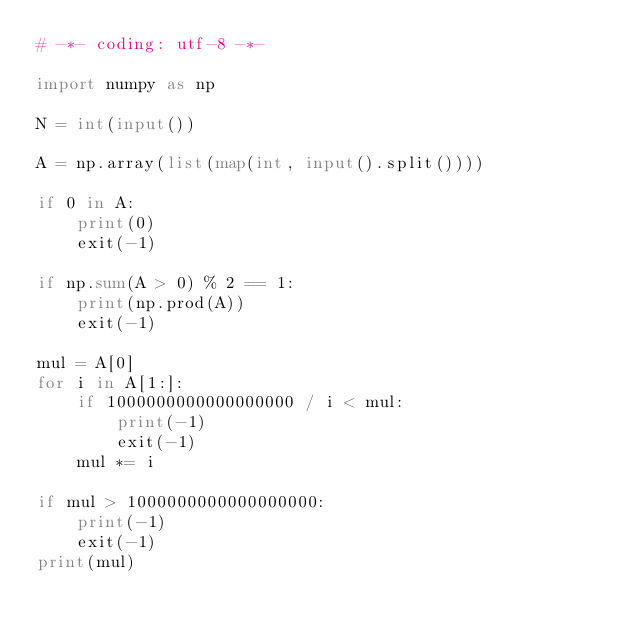Convert code to text. <code><loc_0><loc_0><loc_500><loc_500><_Python_># -*- coding: utf-8 -*-

import numpy as np

N = int(input())

A = np.array(list(map(int, input().split())))

if 0 in A:
    print(0)
    exit(-1)

if np.sum(A > 0) % 2 == 1:
    print(np.prod(A))
    exit(-1)

mul = A[0]
for i in A[1:]:
    if 1000000000000000000 / i < mul:
        print(-1)
        exit(-1)
    mul *= i

if mul > 1000000000000000000:
    print(-1)
    exit(-1)
print(mul)</code> 